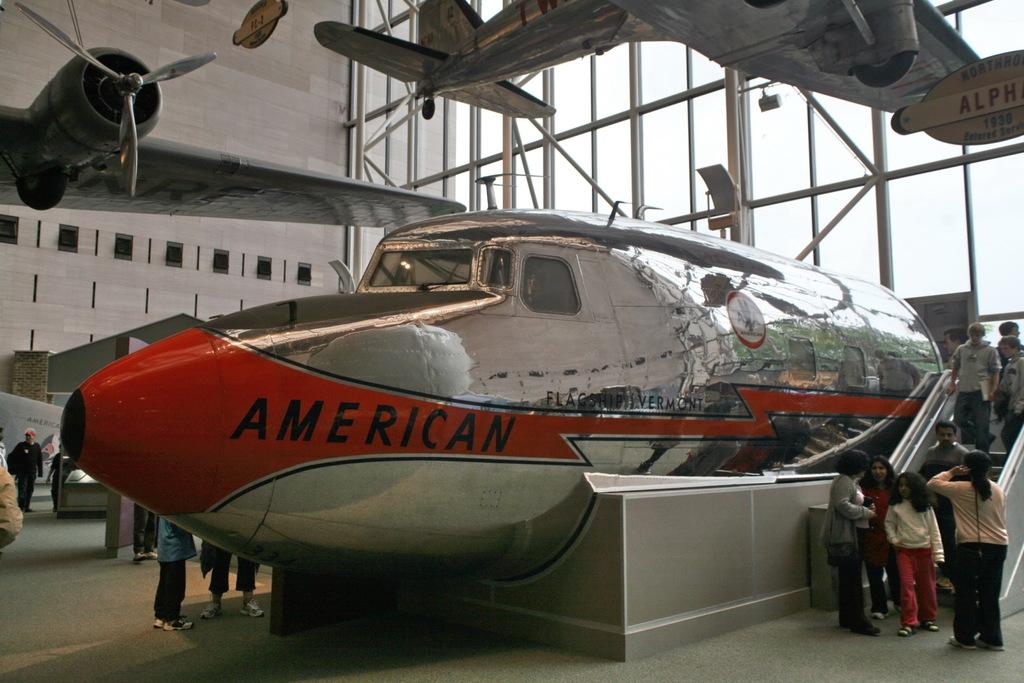Is this an american plane?
Offer a terse response. Yes. 